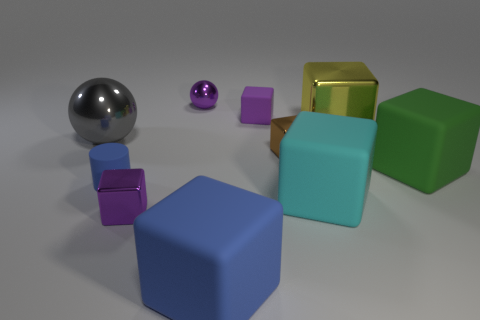Subtract all green cylinders. How many purple blocks are left? 2 Subtract all tiny rubber blocks. How many blocks are left? 6 Subtract 3 cubes. How many cubes are left? 4 Subtract all brown cubes. How many cubes are left? 6 Subtract all gray cubes. Subtract all red cylinders. How many cubes are left? 7 Subtract all blocks. How many objects are left? 3 Subtract all big gray shiny objects. Subtract all brown metal blocks. How many objects are left? 8 Add 4 small metal spheres. How many small metal spheres are left? 5 Add 8 green blocks. How many green blocks exist? 9 Subtract 1 blue cubes. How many objects are left? 9 